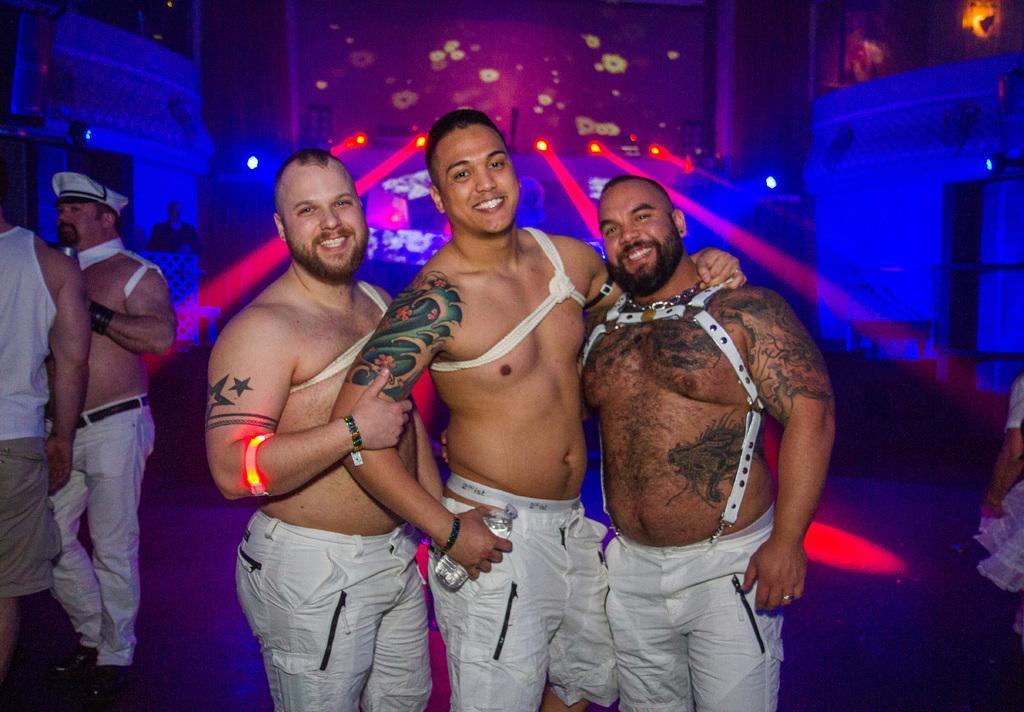In one or two sentences, can you explain what this image depicts? In this image I can see there are three persons standing on the ground and they are smiling , on the left side I can see two persons and at the top I can see colorful wall and I can see lights visible on the wall. 